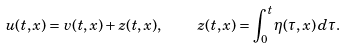Convert formula to latex. <formula><loc_0><loc_0><loc_500><loc_500>u ( t , x ) = v ( t , x ) + z ( t , x ) , \quad z ( t , x ) = \int _ { 0 } ^ { t } \eta ( \tau , x ) \, d \tau .</formula> 